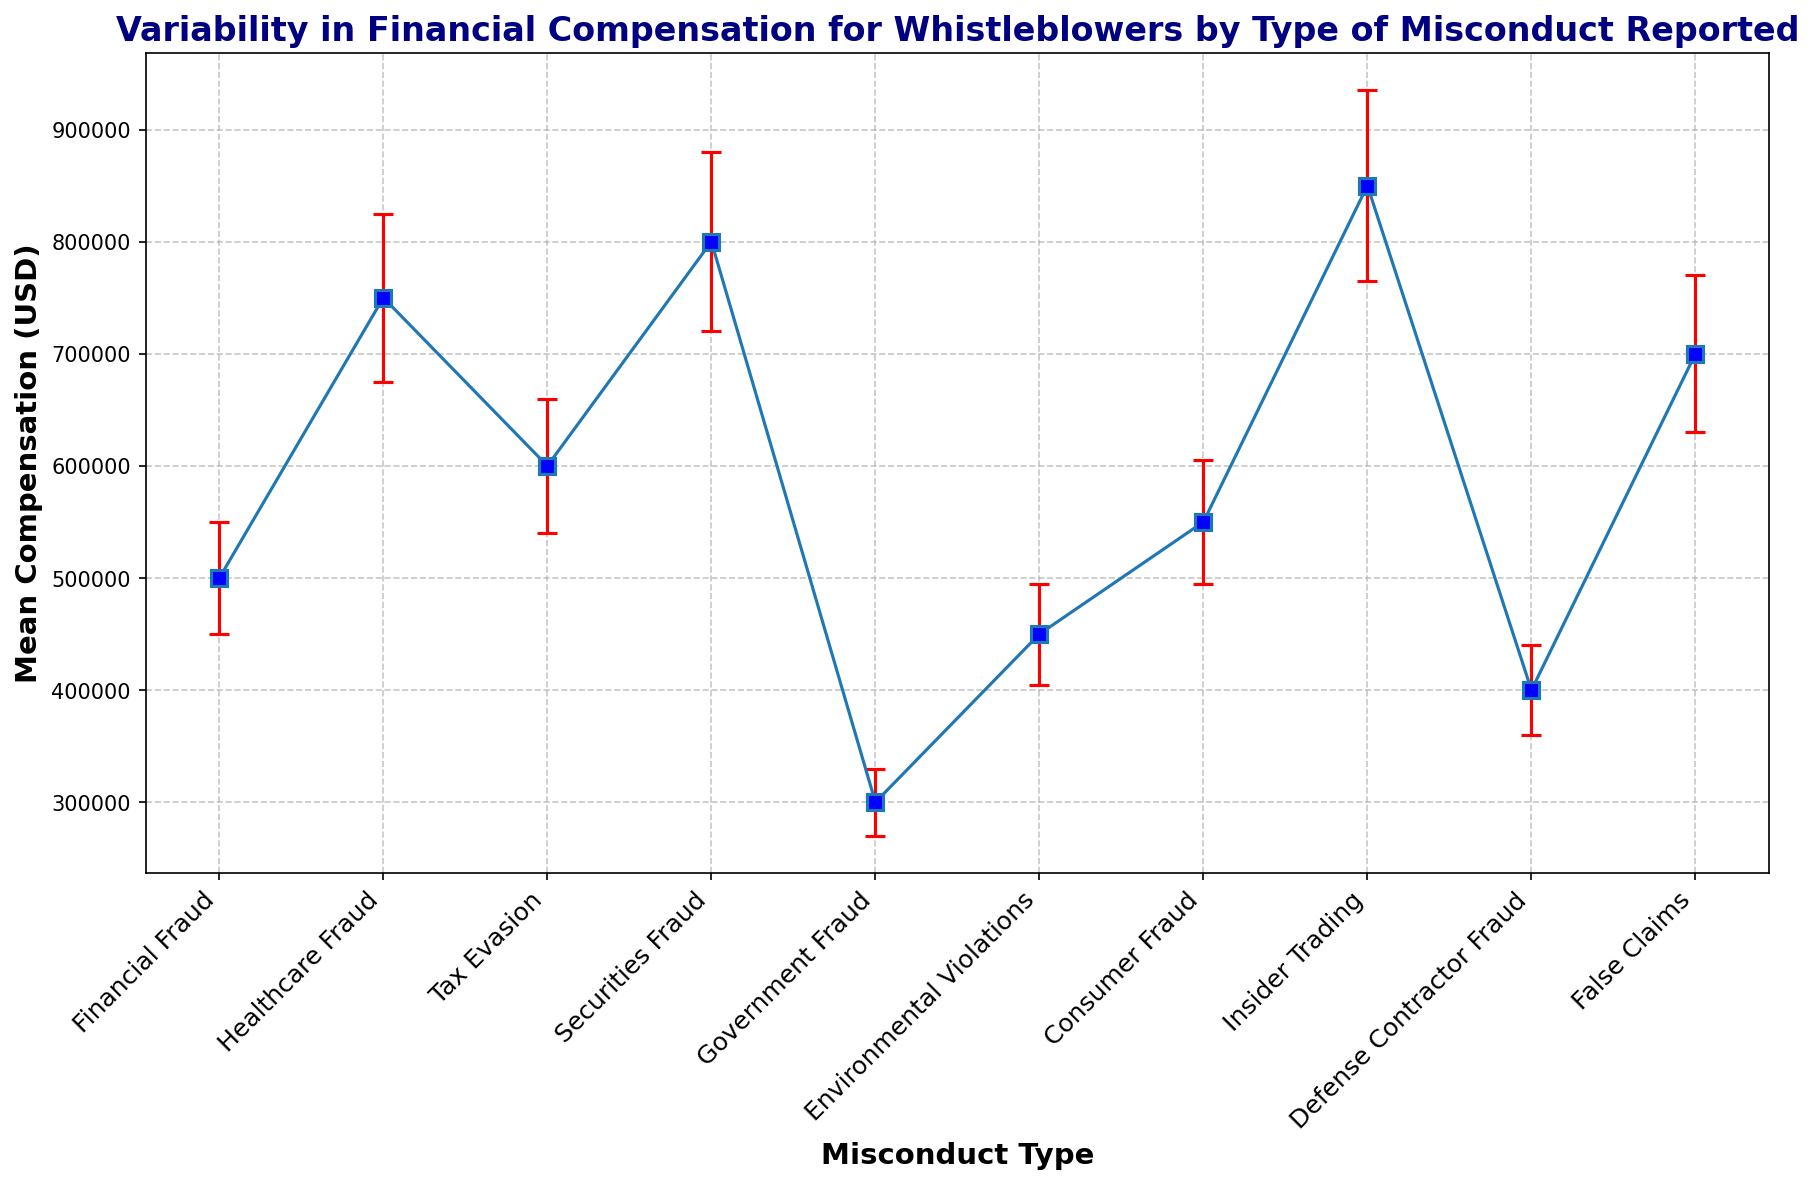What is the discrepancy between the highest and lowest mean compensations reported for whistleblowers by type of misconduct? Find the highest and lowest mean compensation values: Highest = $850,000 (Insider Trading), Lowest = $300,000 (Government Fraud). The discrepancy is $850,000 - $300,000.
Answer: $550,000 Which type of misconduct reported has the highest mean compensation for whistleblowers? Look for the data point with the highest mean compensation value, which is $850,000.
Answer: Insider Trading Compared to Financial Fraud, how much higher is the mean compensation for Healthcare Fraud? Mean compensations: Healthcare Fraud = $750,000, Financial Fraud = $500,000. The difference is $750,000 - $500,000.
Answer: $250,000 What is the total mean compensation for whistleblowers reporting Environmental Violations and Defense Contractor Fraud combined? Sum the mean compensations for the two types: Environmental Violations ($450,000) + Defense Contractor Fraud ($400,000).
Answer: $850,000 For which type of misconduct does the error interval range the widest? Compare the error intervals (Upper Interval - Lower Interval) for each type: The widest range is for Insider Trading ($935,000 - $765,000 = $170,000).
Answer: Insider Trading How does the mean compensation for Consumer Fraud compare to that of Financial Fraud? Mean compensations: Consumer Fraud = $550,000, Financial Fraud = $500,000. Consumer Fraud is $50,000 higher.
Answer: $50,000 higher Which three types of misconduct have mean compensations exceeding $700,000? Identify the misconducts with mean compensation values above $700,000: Healthcare Fraud ($750,000), Securities Fraud ($800,000), Insider Trading ($850,000).
Answer: Healthcare Fraud, Securities Fraud, Insider Trading What is the mean difference in compensations between False Claims and Tax Evasion? Mean compensations: False Claims = $700,000, Tax Evasion = $600,000. The difference is $700,000 - $600,000.
Answer: $100,000 